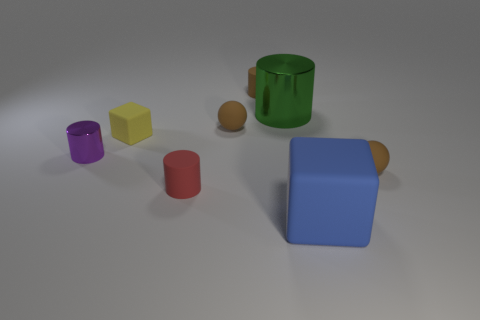Subtract all small brown rubber cylinders. How many cylinders are left? 3 Add 1 tiny cylinders. How many objects exist? 9 Subtract 1 blocks. How many blocks are left? 1 Subtract all red cylinders. How many cylinders are left? 3 Subtract all balls. How many objects are left? 6 Subtract all blue cylinders. How many cyan balls are left? 0 Subtract 1 red cylinders. How many objects are left? 7 Subtract all gray balls. Subtract all gray cylinders. How many balls are left? 2 Subtract all balls. Subtract all red things. How many objects are left? 5 Add 8 large matte blocks. How many large matte blocks are left? 9 